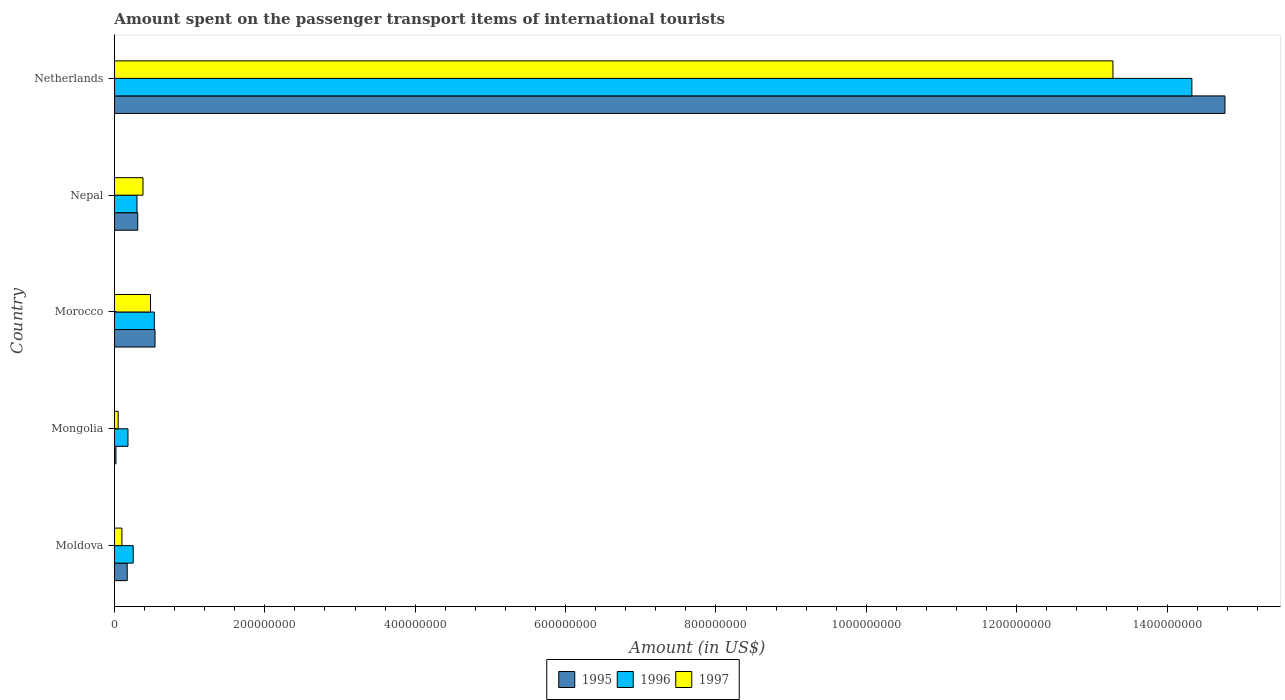How many different coloured bars are there?
Provide a succinct answer. 3. How many groups of bars are there?
Your response must be concise. 5. Are the number of bars per tick equal to the number of legend labels?
Ensure brevity in your answer.  Yes. Are the number of bars on each tick of the Y-axis equal?
Offer a very short reply. Yes. How many bars are there on the 4th tick from the bottom?
Give a very brief answer. 3. What is the label of the 5th group of bars from the top?
Your response must be concise. Moldova. What is the amount spent on the passenger transport items of international tourists in 1996 in Netherlands?
Ensure brevity in your answer.  1.43e+09. Across all countries, what is the maximum amount spent on the passenger transport items of international tourists in 1995?
Give a very brief answer. 1.48e+09. In which country was the amount spent on the passenger transport items of international tourists in 1997 maximum?
Ensure brevity in your answer.  Netherlands. In which country was the amount spent on the passenger transport items of international tourists in 1996 minimum?
Ensure brevity in your answer.  Mongolia. What is the total amount spent on the passenger transport items of international tourists in 1995 in the graph?
Your answer should be very brief. 1.58e+09. What is the difference between the amount spent on the passenger transport items of international tourists in 1996 in Nepal and that in Netherlands?
Make the answer very short. -1.40e+09. What is the difference between the amount spent on the passenger transport items of international tourists in 1997 in Netherlands and the amount spent on the passenger transport items of international tourists in 1995 in Morocco?
Your answer should be very brief. 1.27e+09. What is the average amount spent on the passenger transport items of international tourists in 1995 per country?
Give a very brief answer. 3.16e+08. What is the difference between the amount spent on the passenger transport items of international tourists in 1997 and amount spent on the passenger transport items of international tourists in 1995 in Netherlands?
Provide a succinct answer. -1.49e+08. Is the amount spent on the passenger transport items of international tourists in 1996 in Morocco less than that in Nepal?
Keep it short and to the point. No. Is the difference between the amount spent on the passenger transport items of international tourists in 1997 in Morocco and Nepal greater than the difference between the amount spent on the passenger transport items of international tourists in 1995 in Morocco and Nepal?
Keep it short and to the point. No. What is the difference between the highest and the second highest amount spent on the passenger transport items of international tourists in 1995?
Offer a terse response. 1.42e+09. What is the difference between the highest and the lowest amount spent on the passenger transport items of international tourists in 1997?
Your answer should be compact. 1.32e+09. What does the 3rd bar from the top in Moldova represents?
Make the answer very short. 1995. What does the 1st bar from the bottom in Moldova represents?
Offer a terse response. 1995. What is the difference between two consecutive major ticks on the X-axis?
Ensure brevity in your answer.  2.00e+08. Does the graph contain any zero values?
Provide a succinct answer. No. Where does the legend appear in the graph?
Offer a terse response. Bottom center. How many legend labels are there?
Give a very brief answer. 3. What is the title of the graph?
Give a very brief answer. Amount spent on the passenger transport items of international tourists. Does "1979" appear as one of the legend labels in the graph?
Keep it short and to the point. No. What is the label or title of the X-axis?
Ensure brevity in your answer.  Amount (in US$). What is the label or title of the Y-axis?
Keep it short and to the point. Country. What is the Amount (in US$) in 1995 in Moldova?
Offer a very short reply. 1.70e+07. What is the Amount (in US$) of 1996 in Moldova?
Give a very brief answer. 2.50e+07. What is the Amount (in US$) in 1995 in Mongolia?
Provide a succinct answer. 2.00e+06. What is the Amount (in US$) of 1996 in Mongolia?
Offer a terse response. 1.80e+07. What is the Amount (in US$) in 1995 in Morocco?
Your response must be concise. 5.40e+07. What is the Amount (in US$) in 1996 in Morocco?
Provide a short and direct response. 5.30e+07. What is the Amount (in US$) in 1997 in Morocco?
Offer a terse response. 4.80e+07. What is the Amount (in US$) in 1995 in Nepal?
Give a very brief answer. 3.10e+07. What is the Amount (in US$) in 1996 in Nepal?
Your response must be concise. 3.00e+07. What is the Amount (in US$) in 1997 in Nepal?
Your answer should be compact. 3.80e+07. What is the Amount (in US$) of 1995 in Netherlands?
Provide a succinct answer. 1.48e+09. What is the Amount (in US$) of 1996 in Netherlands?
Offer a terse response. 1.43e+09. What is the Amount (in US$) of 1997 in Netherlands?
Ensure brevity in your answer.  1.33e+09. Across all countries, what is the maximum Amount (in US$) in 1995?
Provide a short and direct response. 1.48e+09. Across all countries, what is the maximum Amount (in US$) in 1996?
Provide a succinct answer. 1.43e+09. Across all countries, what is the maximum Amount (in US$) in 1997?
Give a very brief answer. 1.33e+09. Across all countries, what is the minimum Amount (in US$) of 1996?
Offer a very short reply. 1.80e+07. What is the total Amount (in US$) in 1995 in the graph?
Your answer should be compact. 1.58e+09. What is the total Amount (in US$) in 1996 in the graph?
Provide a succinct answer. 1.56e+09. What is the total Amount (in US$) in 1997 in the graph?
Keep it short and to the point. 1.43e+09. What is the difference between the Amount (in US$) in 1995 in Moldova and that in Mongolia?
Your answer should be compact. 1.50e+07. What is the difference between the Amount (in US$) in 1995 in Moldova and that in Morocco?
Give a very brief answer. -3.70e+07. What is the difference between the Amount (in US$) in 1996 in Moldova and that in Morocco?
Ensure brevity in your answer.  -2.80e+07. What is the difference between the Amount (in US$) in 1997 in Moldova and that in Morocco?
Make the answer very short. -3.80e+07. What is the difference between the Amount (in US$) in 1995 in Moldova and that in Nepal?
Make the answer very short. -1.40e+07. What is the difference between the Amount (in US$) of 1996 in Moldova and that in Nepal?
Your answer should be very brief. -5.00e+06. What is the difference between the Amount (in US$) of 1997 in Moldova and that in Nepal?
Ensure brevity in your answer.  -2.80e+07. What is the difference between the Amount (in US$) in 1995 in Moldova and that in Netherlands?
Your answer should be very brief. -1.46e+09. What is the difference between the Amount (in US$) of 1996 in Moldova and that in Netherlands?
Ensure brevity in your answer.  -1.41e+09. What is the difference between the Amount (in US$) of 1997 in Moldova and that in Netherlands?
Provide a short and direct response. -1.32e+09. What is the difference between the Amount (in US$) in 1995 in Mongolia and that in Morocco?
Your answer should be compact. -5.20e+07. What is the difference between the Amount (in US$) in 1996 in Mongolia and that in Morocco?
Offer a terse response. -3.50e+07. What is the difference between the Amount (in US$) in 1997 in Mongolia and that in Morocco?
Your response must be concise. -4.30e+07. What is the difference between the Amount (in US$) of 1995 in Mongolia and that in Nepal?
Provide a succinct answer. -2.90e+07. What is the difference between the Amount (in US$) in 1996 in Mongolia and that in Nepal?
Ensure brevity in your answer.  -1.20e+07. What is the difference between the Amount (in US$) of 1997 in Mongolia and that in Nepal?
Keep it short and to the point. -3.30e+07. What is the difference between the Amount (in US$) of 1995 in Mongolia and that in Netherlands?
Provide a succinct answer. -1.48e+09. What is the difference between the Amount (in US$) in 1996 in Mongolia and that in Netherlands?
Make the answer very short. -1.42e+09. What is the difference between the Amount (in US$) in 1997 in Mongolia and that in Netherlands?
Provide a succinct answer. -1.32e+09. What is the difference between the Amount (in US$) in 1995 in Morocco and that in Nepal?
Give a very brief answer. 2.30e+07. What is the difference between the Amount (in US$) in 1996 in Morocco and that in Nepal?
Keep it short and to the point. 2.30e+07. What is the difference between the Amount (in US$) in 1995 in Morocco and that in Netherlands?
Provide a succinct answer. -1.42e+09. What is the difference between the Amount (in US$) of 1996 in Morocco and that in Netherlands?
Your response must be concise. -1.38e+09. What is the difference between the Amount (in US$) in 1997 in Morocco and that in Netherlands?
Your response must be concise. -1.28e+09. What is the difference between the Amount (in US$) of 1995 in Nepal and that in Netherlands?
Offer a terse response. -1.45e+09. What is the difference between the Amount (in US$) in 1996 in Nepal and that in Netherlands?
Offer a very short reply. -1.40e+09. What is the difference between the Amount (in US$) in 1997 in Nepal and that in Netherlands?
Provide a succinct answer. -1.29e+09. What is the difference between the Amount (in US$) of 1995 in Moldova and the Amount (in US$) of 1996 in Mongolia?
Offer a terse response. -1.00e+06. What is the difference between the Amount (in US$) in 1995 in Moldova and the Amount (in US$) in 1997 in Mongolia?
Keep it short and to the point. 1.20e+07. What is the difference between the Amount (in US$) in 1995 in Moldova and the Amount (in US$) in 1996 in Morocco?
Your answer should be compact. -3.60e+07. What is the difference between the Amount (in US$) in 1995 in Moldova and the Amount (in US$) in 1997 in Morocco?
Your answer should be compact. -3.10e+07. What is the difference between the Amount (in US$) in 1996 in Moldova and the Amount (in US$) in 1997 in Morocco?
Offer a very short reply. -2.30e+07. What is the difference between the Amount (in US$) in 1995 in Moldova and the Amount (in US$) in 1996 in Nepal?
Your answer should be very brief. -1.30e+07. What is the difference between the Amount (in US$) in 1995 in Moldova and the Amount (in US$) in 1997 in Nepal?
Keep it short and to the point. -2.10e+07. What is the difference between the Amount (in US$) in 1996 in Moldova and the Amount (in US$) in 1997 in Nepal?
Ensure brevity in your answer.  -1.30e+07. What is the difference between the Amount (in US$) of 1995 in Moldova and the Amount (in US$) of 1996 in Netherlands?
Offer a very short reply. -1.42e+09. What is the difference between the Amount (in US$) in 1995 in Moldova and the Amount (in US$) in 1997 in Netherlands?
Ensure brevity in your answer.  -1.31e+09. What is the difference between the Amount (in US$) of 1996 in Moldova and the Amount (in US$) of 1997 in Netherlands?
Your answer should be compact. -1.30e+09. What is the difference between the Amount (in US$) in 1995 in Mongolia and the Amount (in US$) in 1996 in Morocco?
Ensure brevity in your answer.  -5.10e+07. What is the difference between the Amount (in US$) of 1995 in Mongolia and the Amount (in US$) of 1997 in Morocco?
Provide a short and direct response. -4.60e+07. What is the difference between the Amount (in US$) in 1996 in Mongolia and the Amount (in US$) in 1997 in Morocco?
Your answer should be very brief. -3.00e+07. What is the difference between the Amount (in US$) of 1995 in Mongolia and the Amount (in US$) of 1996 in Nepal?
Your answer should be very brief. -2.80e+07. What is the difference between the Amount (in US$) of 1995 in Mongolia and the Amount (in US$) of 1997 in Nepal?
Your response must be concise. -3.60e+07. What is the difference between the Amount (in US$) in 1996 in Mongolia and the Amount (in US$) in 1997 in Nepal?
Your answer should be compact. -2.00e+07. What is the difference between the Amount (in US$) of 1995 in Mongolia and the Amount (in US$) of 1996 in Netherlands?
Make the answer very short. -1.43e+09. What is the difference between the Amount (in US$) of 1995 in Mongolia and the Amount (in US$) of 1997 in Netherlands?
Your answer should be compact. -1.33e+09. What is the difference between the Amount (in US$) of 1996 in Mongolia and the Amount (in US$) of 1997 in Netherlands?
Your answer should be very brief. -1.31e+09. What is the difference between the Amount (in US$) in 1995 in Morocco and the Amount (in US$) in 1996 in Nepal?
Offer a very short reply. 2.40e+07. What is the difference between the Amount (in US$) in 1995 in Morocco and the Amount (in US$) in 1997 in Nepal?
Give a very brief answer. 1.60e+07. What is the difference between the Amount (in US$) in 1996 in Morocco and the Amount (in US$) in 1997 in Nepal?
Give a very brief answer. 1.50e+07. What is the difference between the Amount (in US$) of 1995 in Morocco and the Amount (in US$) of 1996 in Netherlands?
Offer a very short reply. -1.38e+09. What is the difference between the Amount (in US$) in 1995 in Morocco and the Amount (in US$) in 1997 in Netherlands?
Ensure brevity in your answer.  -1.27e+09. What is the difference between the Amount (in US$) of 1996 in Morocco and the Amount (in US$) of 1997 in Netherlands?
Provide a succinct answer. -1.28e+09. What is the difference between the Amount (in US$) in 1995 in Nepal and the Amount (in US$) in 1996 in Netherlands?
Give a very brief answer. -1.40e+09. What is the difference between the Amount (in US$) of 1995 in Nepal and the Amount (in US$) of 1997 in Netherlands?
Keep it short and to the point. -1.30e+09. What is the difference between the Amount (in US$) in 1996 in Nepal and the Amount (in US$) in 1997 in Netherlands?
Offer a very short reply. -1.30e+09. What is the average Amount (in US$) of 1995 per country?
Your answer should be compact. 3.16e+08. What is the average Amount (in US$) of 1996 per country?
Keep it short and to the point. 3.12e+08. What is the average Amount (in US$) of 1997 per country?
Offer a terse response. 2.86e+08. What is the difference between the Amount (in US$) of 1995 and Amount (in US$) of 1996 in Moldova?
Give a very brief answer. -8.00e+06. What is the difference between the Amount (in US$) in 1996 and Amount (in US$) in 1997 in Moldova?
Provide a succinct answer. 1.50e+07. What is the difference between the Amount (in US$) of 1995 and Amount (in US$) of 1996 in Mongolia?
Your response must be concise. -1.60e+07. What is the difference between the Amount (in US$) of 1996 and Amount (in US$) of 1997 in Mongolia?
Offer a very short reply. 1.30e+07. What is the difference between the Amount (in US$) in 1995 and Amount (in US$) in 1996 in Morocco?
Ensure brevity in your answer.  1.00e+06. What is the difference between the Amount (in US$) in 1996 and Amount (in US$) in 1997 in Morocco?
Provide a short and direct response. 5.00e+06. What is the difference between the Amount (in US$) in 1995 and Amount (in US$) in 1997 in Nepal?
Make the answer very short. -7.00e+06. What is the difference between the Amount (in US$) of 1996 and Amount (in US$) of 1997 in Nepal?
Offer a terse response. -8.00e+06. What is the difference between the Amount (in US$) of 1995 and Amount (in US$) of 1996 in Netherlands?
Ensure brevity in your answer.  4.40e+07. What is the difference between the Amount (in US$) of 1995 and Amount (in US$) of 1997 in Netherlands?
Make the answer very short. 1.49e+08. What is the difference between the Amount (in US$) of 1996 and Amount (in US$) of 1997 in Netherlands?
Give a very brief answer. 1.05e+08. What is the ratio of the Amount (in US$) in 1995 in Moldova to that in Mongolia?
Ensure brevity in your answer.  8.5. What is the ratio of the Amount (in US$) of 1996 in Moldova to that in Mongolia?
Your answer should be compact. 1.39. What is the ratio of the Amount (in US$) in 1995 in Moldova to that in Morocco?
Give a very brief answer. 0.31. What is the ratio of the Amount (in US$) of 1996 in Moldova to that in Morocco?
Give a very brief answer. 0.47. What is the ratio of the Amount (in US$) in 1997 in Moldova to that in Morocco?
Give a very brief answer. 0.21. What is the ratio of the Amount (in US$) in 1995 in Moldova to that in Nepal?
Your answer should be compact. 0.55. What is the ratio of the Amount (in US$) of 1996 in Moldova to that in Nepal?
Provide a succinct answer. 0.83. What is the ratio of the Amount (in US$) in 1997 in Moldova to that in Nepal?
Your answer should be very brief. 0.26. What is the ratio of the Amount (in US$) of 1995 in Moldova to that in Netherlands?
Give a very brief answer. 0.01. What is the ratio of the Amount (in US$) in 1996 in Moldova to that in Netherlands?
Provide a short and direct response. 0.02. What is the ratio of the Amount (in US$) in 1997 in Moldova to that in Netherlands?
Keep it short and to the point. 0.01. What is the ratio of the Amount (in US$) in 1995 in Mongolia to that in Morocco?
Your answer should be very brief. 0.04. What is the ratio of the Amount (in US$) of 1996 in Mongolia to that in Morocco?
Make the answer very short. 0.34. What is the ratio of the Amount (in US$) of 1997 in Mongolia to that in Morocco?
Your answer should be very brief. 0.1. What is the ratio of the Amount (in US$) in 1995 in Mongolia to that in Nepal?
Offer a terse response. 0.06. What is the ratio of the Amount (in US$) in 1997 in Mongolia to that in Nepal?
Keep it short and to the point. 0.13. What is the ratio of the Amount (in US$) of 1995 in Mongolia to that in Netherlands?
Ensure brevity in your answer.  0. What is the ratio of the Amount (in US$) in 1996 in Mongolia to that in Netherlands?
Offer a very short reply. 0.01. What is the ratio of the Amount (in US$) in 1997 in Mongolia to that in Netherlands?
Give a very brief answer. 0. What is the ratio of the Amount (in US$) of 1995 in Morocco to that in Nepal?
Provide a succinct answer. 1.74. What is the ratio of the Amount (in US$) in 1996 in Morocco to that in Nepal?
Provide a succinct answer. 1.77. What is the ratio of the Amount (in US$) in 1997 in Morocco to that in Nepal?
Make the answer very short. 1.26. What is the ratio of the Amount (in US$) in 1995 in Morocco to that in Netherlands?
Your answer should be compact. 0.04. What is the ratio of the Amount (in US$) of 1996 in Morocco to that in Netherlands?
Your response must be concise. 0.04. What is the ratio of the Amount (in US$) in 1997 in Morocco to that in Netherlands?
Ensure brevity in your answer.  0.04. What is the ratio of the Amount (in US$) in 1995 in Nepal to that in Netherlands?
Provide a succinct answer. 0.02. What is the ratio of the Amount (in US$) in 1996 in Nepal to that in Netherlands?
Keep it short and to the point. 0.02. What is the ratio of the Amount (in US$) in 1997 in Nepal to that in Netherlands?
Your response must be concise. 0.03. What is the difference between the highest and the second highest Amount (in US$) in 1995?
Provide a succinct answer. 1.42e+09. What is the difference between the highest and the second highest Amount (in US$) in 1996?
Provide a succinct answer. 1.38e+09. What is the difference between the highest and the second highest Amount (in US$) of 1997?
Your answer should be compact. 1.28e+09. What is the difference between the highest and the lowest Amount (in US$) of 1995?
Your response must be concise. 1.48e+09. What is the difference between the highest and the lowest Amount (in US$) of 1996?
Your answer should be compact. 1.42e+09. What is the difference between the highest and the lowest Amount (in US$) in 1997?
Your response must be concise. 1.32e+09. 